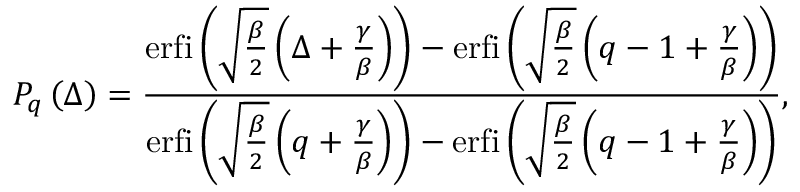<formula> <loc_0><loc_0><loc_500><loc_500>P _ { q } \left ( \Delta \right ) = \frac { e r f i \left ( \sqrt { \frac { \beta } { 2 } } \left ( \Delta + \frac { \gamma } { \beta } \right ) \right ) - e r f i \left ( \sqrt { \frac { \beta } { 2 } } \left ( q - 1 + \frac { \gamma } { \beta } \right ) \right ) } { e r f i \left ( \sqrt { \frac { \beta } { 2 } } \left ( q + \frac { \gamma } { \beta } \right ) \right ) - { e r f i \left ( \sqrt { \frac { \beta } { 2 } } \left ( q - 1 + \frac { \gamma } { \beta } \right ) \right ) } } ,</formula> 